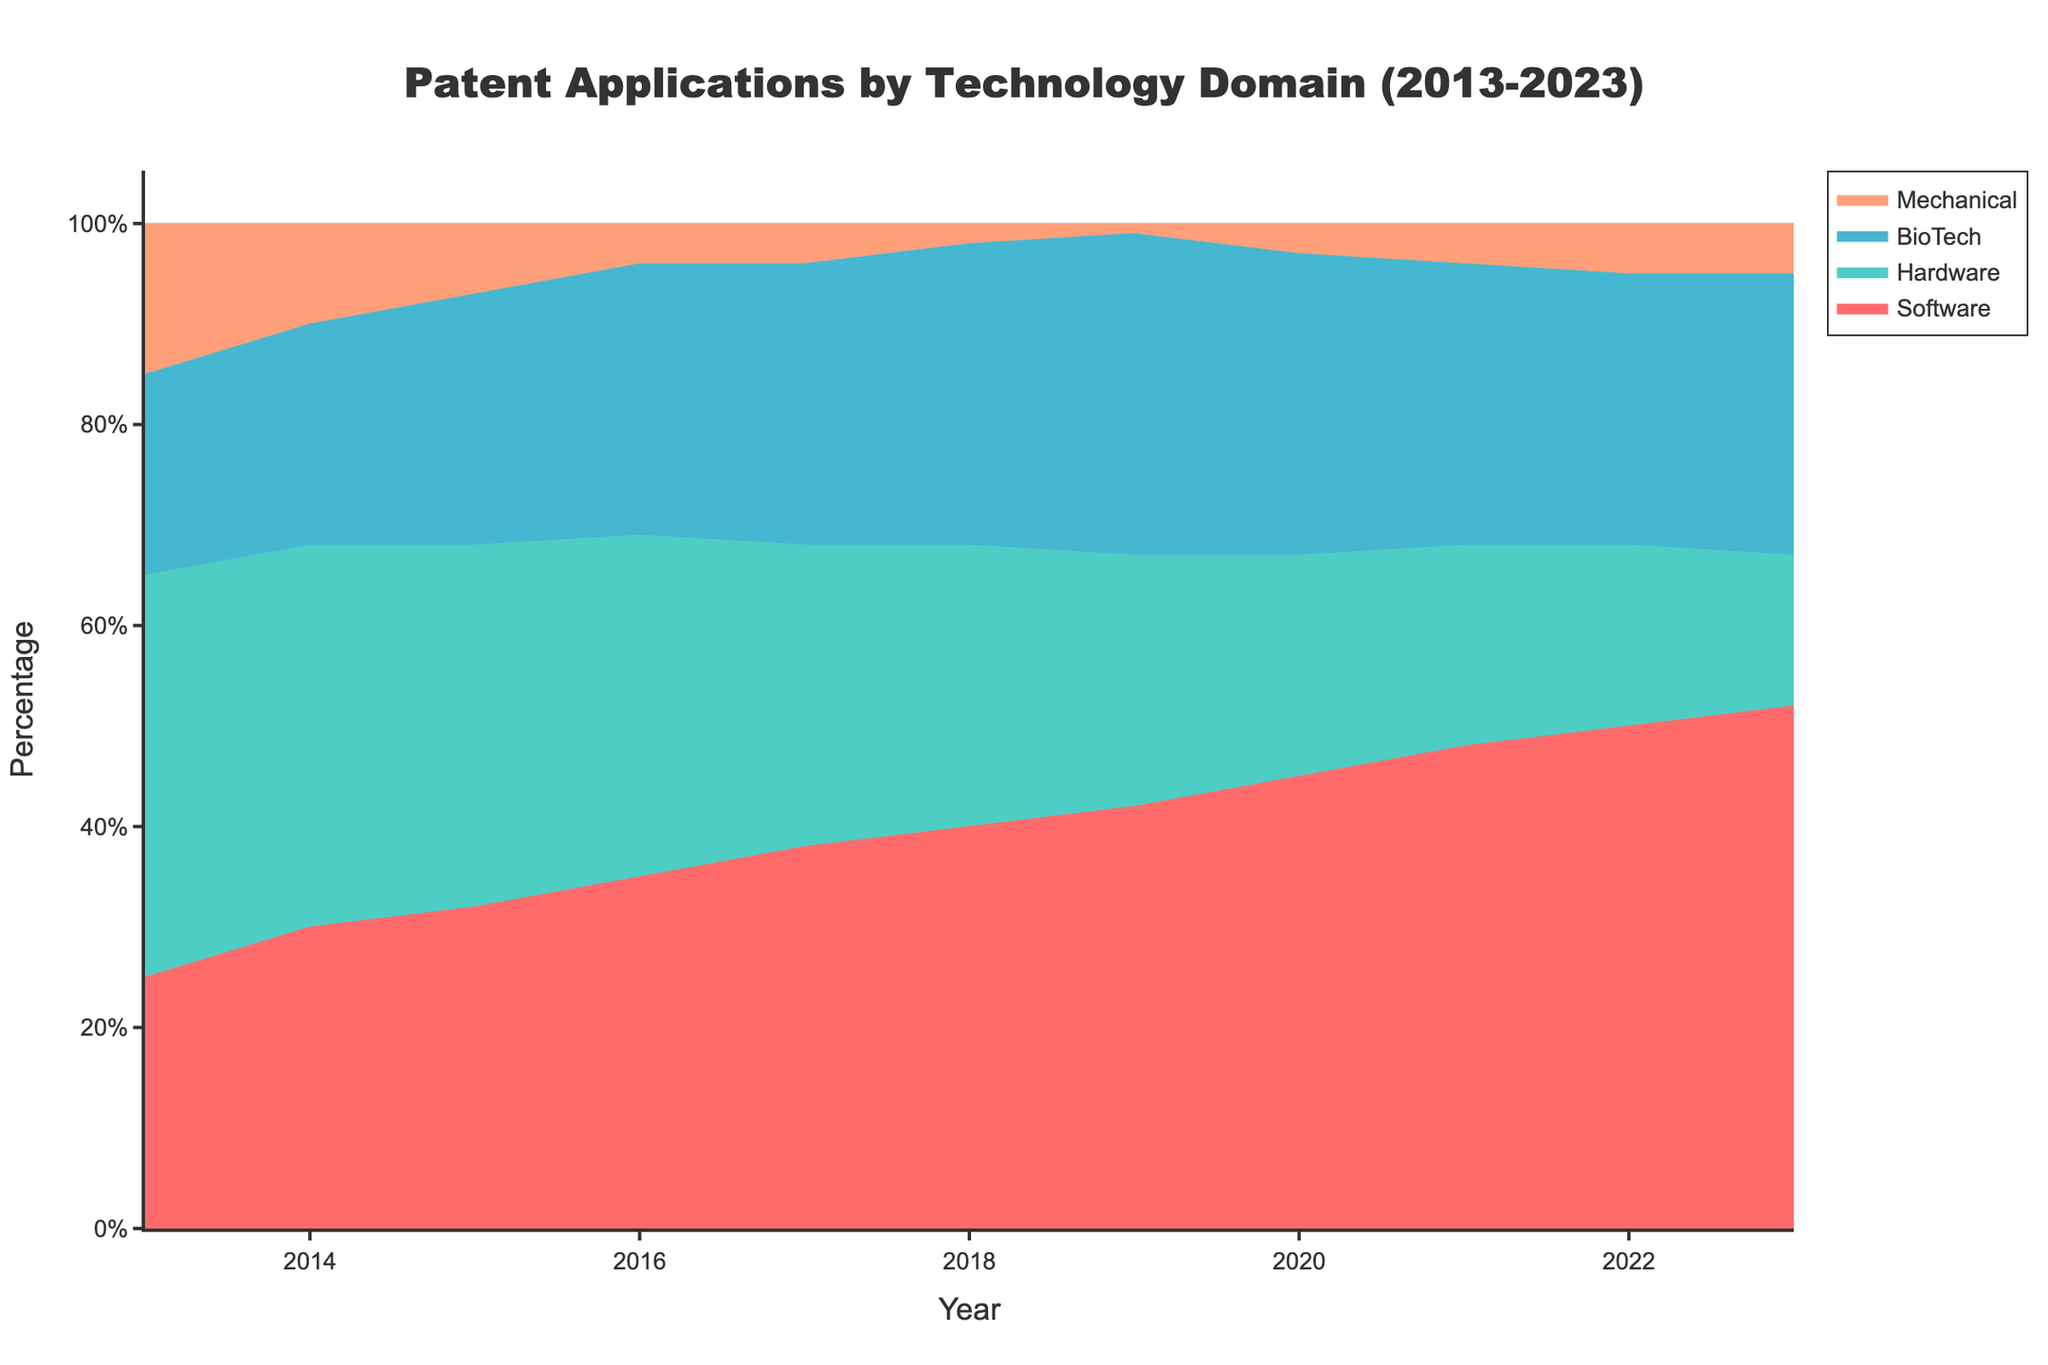What is the title of the chart? The title is displayed prominently at the top of the chart. It reads "Patent Applications by Technology Domain (2013-2023)"
Answer: Patent Applications by Technology Domain (2013-2023) Which technology domain had the highest percentage of patent applications in 2023? By looking at the topmost segment of the stacked area for 2023, which is colored differently from the other segments, we can see that Software has the largest area.
Answer: Software What is the percentage difference between Software and BioTech patent applications in 2020? First, identify the percentages for Software and BioTech in 2020. Software has around 45%, and BioTech has around 30%. Subtract BioTech from Software to get the difference: 45% - 30% = 15%
Answer: 15% Compare the trend of Hardware patent applications from 2013 to 2023. How would you describe it? Observe the line corresponding to Hardware, which starts around 40% in 2013 and decreases steadily to 15% in 2023.
Answer: Steadily decreasing Which year did BioTech surpass Mechanical patent applications? Look at the points where the BioTech area overtakes the Mechanical area. This change happens between 2015 and 2016.
Answer: 2015 How many technology domains are visualized in the chart? Count the number of different segments (areas) in the stacked area chart, which represent the different technology domains. The chart includes Software, Hardware, BioTech, and Mechanical.
Answer: 4 In which year did Software and Hardware combined make up exactly 67% of patent applications? Visually sum the areas for Software and Hardware for each year and look for when their combined percentage is approximately 67%. This happens around 2015 (32% + 36% = 68%, which is close to 67%).
Answer: 2015 What is the general trend for Mechanical patent applications from 2013 to 2023? Observe the color segment representing Mechanical, which starts around 15% in 2013 and gradually decreases to around 5% by 2023.
Answer: Gradually decreasing Which technology domain saw the most significant increase in the percentage of patent applications over the ten years? Observe the relative increase in the area size. Software starts at 25% in 2013 and grows to 52% in 2023, representing the most significant increase among the domains.
Answer: Software How does the percentage of BioTech patent applications in 2022 compare to 2014? Observe the BioTech segments in both years. In 2014, it's around 22%, and in 2022, it's about 27%. The percentage has increased.
Answer: Increased 